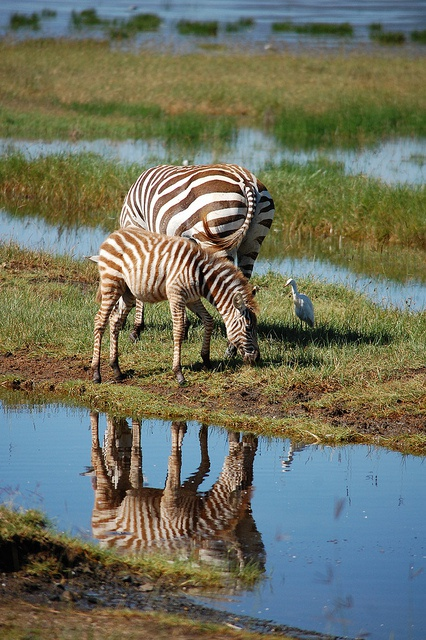Describe the objects in this image and their specific colors. I can see zebra in gray, lightgray, black, maroon, and tan tones, zebra in gray, white, and black tones, and bird in gray, black, blue, and olive tones in this image. 